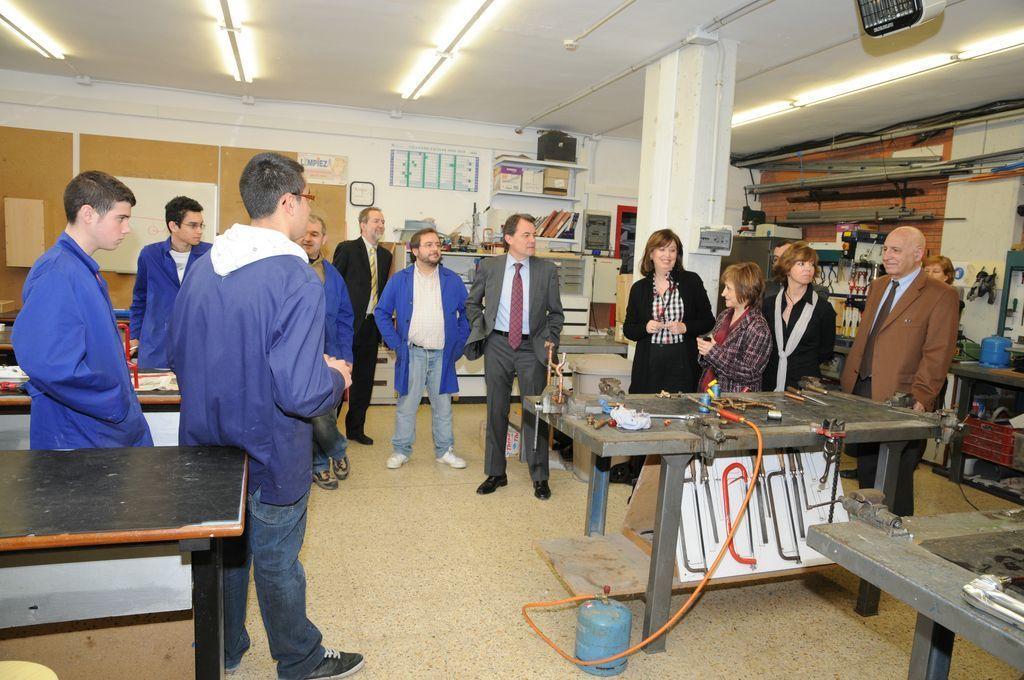Could you give a brief overview of what you see in this image? In this picture we can see some group of people who are all standing, in front of them we can see some tools on the table and we we can see gas cylinder and some hardware parts. 